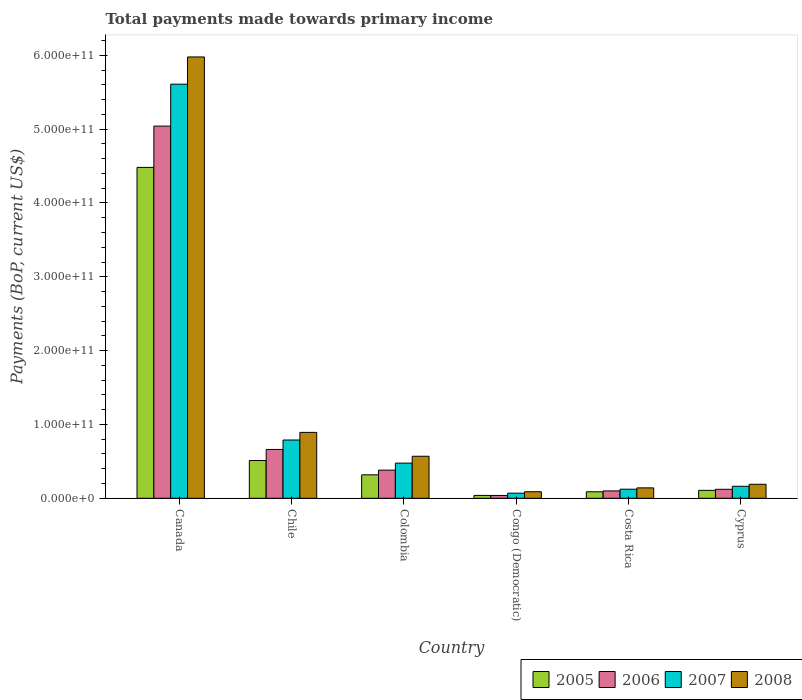How many different coloured bars are there?
Your response must be concise. 4. How many groups of bars are there?
Offer a very short reply. 6. Are the number of bars on each tick of the X-axis equal?
Ensure brevity in your answer.  Yes. How many bars are there on the 3rd tick from the left?
Offer a very short reply. 4. How many bars are there on the 3rd tick from the right?
Provide a short and direct response. 4. What is the label of the 4th group of bars from the left?
Make the answer very short. Congo (Democratic). What is the total payments made towards primary income in 2008 in Congo (Democratic)?
Keep it short and to the point. 8.86e+09. Across all countries, what is the maximum total payments made towards primary income in 2007?
Give a very brief answer. 5.61e+11. Across all countries, what is the minimum total payments made towards primary income in 2008?
Make the answer very short. 8.86e+09. In which country was the total payments made towards primary income in 2005 minimum?
Offer a terse response. Congo (Democratic). What is the total total payments made towards primary income in 2007 in the graph?
Provide a succinct answer. 7.23e+11. What is the difference between the total payments made towards primary income in 2008 in Costa Rica and that in Cyprus?
Your answer should be very brief. -4.88e+09. What is the difference between the total payments made towards primary income in 2007 in Congo (Democratic) and the total payments made towards primary income in 2008 in Canada?
Your answer should be very brief. -5.91e+11. What is the average total payments made towards primary income in 2006 per country?
Offer a terse response. 1.06e+11. What is the difference between the total payments made towards primary income of/in 2006 and total payments made towards primary income of/in 2007 in Congo (Democratic)?
Offer a very short reply. -3.07e+09. In how many countries, is the total payments made towards primary income in 2007 greater than 180000000000 US$?
Ensure brevity in your answer.  1. What is the ratio of the total payments made towards primary income in 2005 in Congo (Democratic) to that in Costa Rica?
Offer a very short reply. 0.44. Is the difference between the total payments made towards primary income in 2006 in Chile and Colombia greater than the difference between the total payments made towards primary income in 2007 in Chile and Colombia?
Your response must be concise. No. What is the difference between the highest and the second highest total payments made towards primary income in 2006?
Offer a terse response. 4.38e+11. What is the difference between the highest and the lowest total payments made towards primary income in 2006?
Ensure brevity in your answer.  5.00e+11. In how many countries, is the total payments made towards primary income in 2005 greater than the average total payments made towards primary income in 2005 taken over all countries?
Your response must be concise. 1. Is the sum of the total payments made towards primary income in 2005 in Canada and Colombia greater than the maximum total payments made towards primary income in 2006 across all countries?
Offer a very short reply. No. What does the 4th bar from the left in Congo (Democratic) represents?
Give a very brief answer. 2008. Is it the case that in every country, the sum of the total payments made towards primary income in 2007 and total payments made towards primary income in 2006 is greater than the total payments made towards primary income in 2005?
Offer a terse response. Yes. How many bars are there?
Provide a succinct answer. 24. Are all the bars in the graph horizontal?
Provide a short and direct response. No. How many countries are there in the graph?
Keep it short and to the point. 6. What is the difference between two consecutive major ticks on the Y-axis?
Give a very brief answer. 1.00e+11. Does the graph contain grids?
Your answer should be compact. No. What is the title of the graph?
Offer a terse response. Total payments made towards primary income. Does "1965" appear as one of the legend labels in the graph?
Ensure brevity in your answer.  No. What is the label or title of the X-axis?
Keep it short and to the point. Country. What is the label or title of the Y-axis?
Keep it short and to the point. Payments (BoP, current US$). What is the Payments (BoP, current US$) in 2005 in Canada?
Make the answer very short. 4.48e+11. What is the Payments (BoP, current US$) in 2006 in Canada?
Offer a very short reply. 5.04e+11. What is the Payments (BoP, current US$) of 2007 in Canada?
Your answer should be compact. 5.61e+11. What is the Payments (BoP, current US$) in 2008 in Canada?
Keep it short and to the point. 5.98e+11. What is the Payments (BoP, current US$) in 2005 in Chile?
Your response must be concise. 5.12e+1. What is the Payments (BoP, current US$) of 2006 in Chile?
Keep it short and to the point. 6.61e+1. What is the Payments (BoP, current US$) of 2007 in Chile?
Make the answer very short. 7.89e+1. What is the Payments (BoP, current US$) of 2008 in Chile?
Ensure brevity in your answer.  8.92e+1. What is the Payments (BoP, current US$) in 2005 in Colombia?
Provide a short and direct response. 3.18e+1. What is the Payments (BoP, current US$) in 2006 in Colombia?
Your response must be concise. 3.81e+1. What is the Payments (BoP, current US$) in 2007 in Colombia?
Ensure brevity in your answer.  4.76e+1. What is the Payments (BoP, current US$) of 2008 in Colombia?
Provide a succinct answer. 5.69e+1. What is the Payments (BoP, current US$) of 2005 in Congo (Democratic)?
Make the answer very short. 3.89e+09. What is the Payments (BoP, current US$) in 2006 in Congo (Democratic)?
Offer a terse response. 3.83e+09. What is the Payments (BoP, current US$) of 2007 in Congo (Democratic)?
Make the answer very short. 6.90e+09. What is the Payments (BoP, current US$) of 2008 in Congo (Democratic)?
Provide a short and direct response. 8.86e+09. What is the Payments (BoP, current US$) of 2005 in Costa Rica?
Your response must be concise. 8.79e+09. What is the Payments (BoP, current US$) in 2006 in Costa Rica?
Provide a short and direct response. 9.98e+09. What is the Payments (BoP, current US$) of 2007 in Costa Rica?
Your response must be concise. 1.23e+1. What is the Payments (BoP, current US$) in 2008 in Costa Rica?
Ensure brevity in your answer.  1.41e+1. What is the Payments (BoP, current US$) of 2005 in Cyprus?
Ensure brevity in your answer.  1.07e+1. What is the Payments (BoP, current US$) of 2006 in Cyprus?
Keep it short and to the point. 1.22e+1. What is the Payments (BoP, current US$) in 2007 in Cyprus?
Provide a short and direct response. 1.63e+1. What is the Payments (BoP, current US$) in 2008 in Cyprus?
Give a very brief answer. 1.90e+1. Across all countries, what is the maximum Payments (BoP, current US$) of 2005?
Ensure brevity in your answer.  4.48e+11. Across all countries, what is the maximum Payments (BoP, current US$) of 2006?
Ensure brevity in your answer.  5.04e+11. Across all countries, what is the maximum Payments (BoP, current US$) of 2007?
Your answer should be very brief. 5.61e+11. Across all countries, what is the maximum Payments (BoP, current US$) of 2008?
Give a very brief answer. 5.98e+11. Across all countries, what is the minimum Payments (BoP, current US$) of 2005?
Offer a terse response. 3.89e+09. Across all countries, what is the minimum Payments (BoP, current US$) in 2006?
Your response must be concise. 3.83e+09. Across all countries, what is the minimum Payments (BoP, current US$) of 2007?
Ensure brevity in your answer.  6.90e+09. Across all countries, what is the minimum Payments (BoP, current US$) of 2008?
Your answer should be compact. 8.86e+09. What is the total Payments (BoP, current US$) of 2005 in the graph?
Offer a very short reply. 5.55e+11. What is the total Payments (BoP, current US$) in 2006 in the graph?
Your answer should be very brief. 6.34e+11. What is the total Payments (BoP, current US$) in 2007 in the graph?
Your answer should be very brief. 7.23e+11. What is the total Payments (BoP, current US$) in 2008 in the graph?
Your response must be concise. 7.86e+11. What is the difference between the Payments (BoP, current US$) in 2005 in Canada and that in Chile?
Keep it short and to the point. 3.97e+11. What is the difference between the Payments (BoP, current US$) in 2006 in Canada and that in Chile?
Keep it short and to the point. 4.38e+11. What is the difference between the Payments (BoP, current US$) of 2007 in Canada and that in Chile?
Your answer should be very brief. 4.82e+11. What is the difference between the Payments (BoP, current US$) of 2008 in Canada and that in Chile?
Keep it short and to the point. 5.09e+11. What is the difference between the Payments (BoP, current US$) in 2005 in Canada and that in Colombia?
Offer a very short reply. 4.16e+11. What is the difference between the Payments (BoP, current US$) of 2006 in Canada and that in Colombia?
Provide a succinct answer. 4.66e+11. What is the difference between the Payments (BoP, current US$) of 2007 in Canada and that in Colombia?
Your answer should be compact. 5.13e+11. What is the difference between the Payments (BoP, current US$) of 2008 in Canada and that in Colombia?
Keep it short and to the point. 5.41e+11. What is the difference between the Payments (BoP, current US$) in 2005 in Canada and that in Congo (Democratic)?
Your answer should be compact. 4.44e+11. What is the difference between the Payments (BoP, current US$) of 2006 in Canada and that in Congo (Democratic)?
Make the answer very short. 5.00e+11. What is the difference between the Payments (BoP, current US$) in 2007 in Canada and that in Congo (Democratic)?
Provide a succinct answer. 5.54e+11. What is the difference between the Payments (BoP, current US$) in 2008 in Canada and that in Congo (Democratic)?
Ensure brevity in your answer.  5.89e+11. What is the difference between the Payments (BoP, current US$) of 2005 in Canada and that in Costa Rica?
Provide a short and direct response. 4.39e+11. What is the difference between the Payments (BoP, current US$) in 2006 in Canada and that in Costa Rica?
Keep it short and to the point. 4.94e+11. What is the difference between the Payments (BoP, current US$) in 2007 in Canada and that in Costa Rica?
Provide a succinct answer. 5.49e+11. What is the difference between the Payments (BoP, current US$) in 2008 in Canada and that in Costa Rica?
Keep it short and to the point. 5.84e+11. What is the difference between the Payments (BoP, current US$) of 2005 in Canada and that in Cyprus?
Provide a short and direct response. 4.37e+11. What is the difference between the Payments (BoP, current US$) of 2006 in Canada and that in Cyprus?
Ensure brevity in your answer.  4.92e+11. What is the difference between the Payments (BoP, current US$) of 2007 in Canada and that in Cyprus?
Your answer should be very brief. 5.45e+11. What is the difference between the Payments (BoP, current US$) of 2008 in Canada and that in Cyprus?
Provide a short and direct response. 5.79e+11. What is the difference between the Payments (BoP, current US$) in 2005 in Chile and that in Colombia?
Make the answer very short. 1.94e+1. What is the difference between the Payments (BoP, current US$) of 2006 in Chile and that in Colombia?
Your answer should be very brief. 2.80e+1. What is the difference between the Payments (BoP, current US$) of 2007 in Chile and that in Colombia?
Offer a very short reply. 3.13e+1. What is the difference between the Payments (BoP, current US$) of 2008 in Chile and that in Colombia?
Offer a terse response. 3.23e+1. What is the difference between the Payments (BoP, current US$) in 2005 in Chile and that in Congo (Democratic)?
Offer a very short reply. 4.73e+1. What is the difference between the Payments (BoP, current US$) of 2006 in Chile and that in Congo (Democratic)?
Your response must be concise. 6.23e+1. What is the difference between the Payments (BoP, current US$) in 2007 in Chile and that in Congo (Democratic)?
Provide a succinct answer. 7.20e+1. What is the difference between the Payments (BoP, current US$) of 2008 in Chile and that in Congo (Democratic)?
Provide a succinct answer. 8.04e+1. What is the difference between the Payments (BoP, current US$) of 2005 in Chile and that in Costa Rica?
Give a very brief answer. 4.24e+1. What is the difference between the Payments (BoP, current US$) in 2006 in Chile and that in Costa Rica?
Your answer should be compact. 5.62e+1. What is the difference between the Payments (BoP, current US$) of 2007 in Chile and that in Costa Rica?
Ensure brevity in your answer.  6.66e+1. What is the difference between the Payments (BoP, current US$) of 2008 in Chile and that in Costa Rica?
Your answer should be compact. 7.52e+1. What is the difference between the Payments (BoP, current US$) of 2005 in Chile and that in Cyprus?
Offer a very short reply. 4.04e+1. What is the difference between the Payments (BoP, current US$) of 2006 in Chile and that in Cyprus?
Offer a terse response. 5.40e+1. What is the difference between the Payments (BoP, current US$) in 2007 in Chile and that in Cyprus?
Offer a terse response. 6.27e+1. What is the difference between the Payments (BoP, current US$) of 2008 in Chile and that in Cyprus?
Give a very brief answer. 7.03e+1. What is the difference between the Payments (BoP, current US$) of 2005 in Colombia and that in Congo (Democratic)?
Make the answer very short. 2.79e+1. What is the difference between the Payments (BoP, current US$) of 2006 in Colombia and that in Congo (Democratic)?
Your answer should be very brief. 3.43e+1. What is the difference between the Payments (BoP, current US$) in 2007 in Colombia and that in Congo (Democratic)?
Your answer should be very brief. 4.07e+1. What is the difference between the Payments (BoP, current US$) in 2008 in Colombia and that in Congo (Democratic)?
Keep it short and to the point. 4.81e+1. What is the difference between the Payments (BoP, current US$) in 2005 in Colombia and that in Costa Rica?
Make the answer very short. 2.30e+1. What is the difference between the Payments (BoP, current US$) in 2006 in Colombia and that in Costa Rica?
Keep it short and to the point. 2.81e+1. What is the difference between the Payments (BoP, current US$) of 2007 in Colombia and that in Costa Rica?
Keep it short and to the point. 3.53e+1. What is the difference between the Payments (BoP, current US$) in 2008 in Colombia and that in Costa Rica?
Ensure brevity in your answer.  4.28e+1. What is the difference between the Payments (BoP, current US$) in 2005 in Colombia and that in Cyprus?
Provide a short and direct response. 2.10e+1. What is the difference between the Payments (BoP, current US$) of 2006 in Colombia and that in Cyprus?
Keep it short and to the point. 2.59e+1. What is the difference between the Payments (BoP, current US$) in 2007 in Colombia and that in Cyprus?
Make the answer very short. 3.14e+1. What is the difference between the Payments (BoP, current US$) of 2008 in Colombia and that in Cyprus?
Your response must be concise. 3.80e+1. What is the difference between the Payments (BoP, current US$) in 2005 in Congo (Democratic) and that in Costa Rica?
Your answer should be compact. -4.89e+09. What is the difference between the Payments (BoP, current US$) in 2006 in Congo (Democratic) and that in Costa Rica?
Offer a terse response. -6.15e+09. What is the difference between the Payments (BoP, current US$) of 2007 in Congo (Democratic) and that in Costa Rica?
Your answer should be very brief. -5.40e+09. What is the difference between the Payments (BoP, current US$) of 2008 in Congo (Democratic) and that in Costa Rica?
Ensure brevity in your answer.  -5.23e+09. What is the difference between the Payments (BoP, current US$) in 2005 in Congo (Democratic) and that in Cyprus?
Ensure brevity in your answer.  -6.85e+09. What is the difference between the Payments (BoP, current US$) of 2006 in Congo (Democratic) and that in Cyprus?
Ensure brevity in your answer.  -8.35e+09. What is the difference between the Payments (BoP, current US$) in 2007 in Congo (Democratic) and that in Cyprus?
Provide a succinct answer. -9.37e+09. What is the difference between the Payments (BoP, current US$) in 2008 in Congo (Democratic) and that in Cyprus?
Provide a short and direct response. -1.01e+1. What is the difference between the Payments (BoP, current US$) in 2005 in Costa Rica and that in Cyprus?
Offer a very short reply. -1.96e+09. What is the difference between the Payments (BoP, current US$) of 2006 in Costa Rica and that in Cyprus?
Provide a short and direct response. -2.20e+09. What is the difference between the Payments (BoP, current US$) in 2007 in Costa Rica and that in Cyprus?
Offer a terse response. -3.97e+09. What is the difference between the Payments (BoP, current US$) of 2008 in Costa Rica and that in Cyprus?
Offer a terse response. -4.88e+09. What is the difference between the Payments (BoP, current US$) of 2005 in Canada and the Payments (BoP, current US$) of 2006 in Chile?
Ensure brevity in your answer.  3.82e+11. What is the difference between the Payments (BoP, current US$) in 2005 in Canada and the Payments (BoP, current US$) in 2007 in Chile?
Give a very brief answer. 3.69e+11. What is the difference between the Payments (BoP, current US$) in 2005 in Canada and the Payments (BoP, current US$) in 2008 in Chile?
Provide a succinct answer. 3.59e+11. What is the difference between the Payments (BoP, current US$) in 2006 in Canada and the Payments (BoP, current US$) in 2007 in Chile?
Keep it short and to the point. 4.25e+11. What is the difference between the Payments (BoP, current US$) in 2006 in Canada and the Payments (BoP, current US$) in 2008 in Chile?
Give a very brief answer. 4.15e+11. What is the difference between the Payments (BoP, current US$) in 2007 in Canada and the Payments (BoP, current US$) in 2008 in Chile?
Keep it short and to the point. 4.72e+11. What is the difference between the Payments (BoP, current US$) in 2005 in Canada and the Payments (BoP, current US$) in 2006 in Colombia?
Give a very brief answer. 4.10e+11. What is the difference between the Payments (BoP, current US$) of 2005 in Canada and the Payments (BoP, current US$) of 2007 in Colombia?
Offer a terse response. 4.01e+11. What is the difference between the Payments (BoP, current US$) in 2005 in Canada and the Payments (BoP, current US$) in 2008 in Colombia?
Keep it short and to the point. 3.91e+11. What is the difference between the Payments (BoP, current US$) in 2006 in Canada and the Payments (BoP, current US$) in 2007 in Colombia?
Your answer should be compact. 4.56e+11. What is the difference between the Payments (BoP, current US$) in 2006 in Canada and the Payments (BoP, current US$) in 2008 in Colombia?
Keep it short and to the point. 4.47e+11. What is the difference between the Payments (BoP, current US$) of 2007 in Canada and the Payments (BoP, current US$) of 2008 in Colombia?
Provide a succinct answer. 5.04e+11. What is the difference between the Payments (BoP, current US$) in 2005 in Canada and the Payments (BoP, current US$) in 2006 in Congo (Democratic)?
Provide a succinct answer. 4.44e+11. What is the difference between the Payments (BoP, current US$) of 2005 in Canada and the Payments (BoP, current US$) of 2007 in Congo (Democratic)?
Ensure brevity in your answer.  4.41e+11. What is the difference between the Payments (BoP, current US$) of 2005 in Canada and the Payments (BoP, current US$) of 2008 in Congo (Democratic)?
Provide a succinct answer. 4.39e+11. What is the difference between the Payments (BoP, current US$) in 2006 in Canada and the Payments (BoP, current US$) in 2007 in Congo (Democratic)?
Offer a terse response. 4.97e+11. What is the difference between the Payments (BoP, current US$) in 2006 in Canada and the Payments (BoP, current US$) in 2008 in Congo (Democratic)?
Your response must be concise. 4.95e+11. What is the difference between the Payments (BoP, current US$) in 2007 in Canada and the Payments (BoP, current US$) in 2008 in Congo (Democratic)?
Keep it short and to the point. 5.52e+11. What is the difference between the Payments (BoP, current US$) in 2005 in Canada and the Payments (BoP, current US$) in 2006 in Costa Rica?
Provide a short and direct response. 4.38e+11. What is the difference between the Payments (BoP, current US$) of 2005 in Canada and the Payments (BoP, current US$) of 2007 in Costa Rica?
Your answer should be compact. 4.36e+11. What is the difference between the Payments (BoP, current US$) of 2005 in Canada and the Payments (BoP, current US$) of 2008 in Costa Rica?
Ensure brevity in your answer.  4.34e+11. What is the difference between the Payments (BoP, current US$) in 2006 in Canada and the Payments (BoP, current US$) in 2007 in Costa Rica?
Offer a terse response. 4.92e+11. What is the difference between the Payments (BoP, current US$) in 2006 in Canada and the Payments (BoP, current US$) in 2008 in Costa Rica?
Your response must be concise. 4.90e+11. What is the difference between the Payments (BoP, current US$) of 2007 in Canada and the Payments (BoP, current US$) of 2008 in Costa Rica?
Make the answer very short. 5.47e+11. What is the difference between the Payments (BoP, current US$) of 2005 in Canada and the Payments (BoP, current US$) of 2006 in Cyprus?
Keep it short and to the point. 4.36e+11. What is the difference between the Payments (BoP, current US$) of 2005 in Canada and the Payments (BoP, current US$) of 2007 in Cyprus?
Your answer should be very brief. 4.32e+11. What is the difference between the Payments (BoP, current US$) of 2005 in Canada and the Payments (BoP, current US$) of 2008 in Cyprus?
Make the answer very short. 4.29e+11. What is the difference between the Payments (BoP, current US$) of 2006 in Canada and the Payments (BoP, current US$) of 2007 in Cyprus?
Offer a very short reply. 4.88e+11. What is the difference between the Payments (BoP, current US$) in 2006 in Canada and the Payments (BoP, current US$) in 2008 in Cyprus?
Give a very brief answer. 4.85e+11. What is the difference between the Payments (BoP, current US$) in 2007 in Canada and the Payments (BoP, current US$) in 2008 in Cyprus?
Offer a terse response. 5.42e+11. What is the difference between the Payments (BoP, current US$) of 2005 in Chile and the Payments (BoP, current US$) of 2006 in Colombia?
Ensure brevity in your answer.  1.31e+1. What is the difference between the Payments (BoP, current US$) in 2005 in Chile and the Payments (BoP, current US$) in 2007 in Colombia?
Offer a very short reply. 3.56e+09. What is the difference between the Payments (BoP, current US$) of 2005 in Chile and the Payments (BoP, current US$) of 2008 in Colombia?
Make the answer very short. -5.74e+09. What is the difference between the Payments (BoP, current US$) in 2006 in Chile and the Payments (BoP, current US$) in 2007 in Colombia?
Provide a short and direct response. 1.85e+1. What is the difference between the Payments (BoP, current US$) in 2006 in Chile and the Payments (BoP, current US$) in 2008 in Colombia?
Offer a terse response. 9.21e+09. What is the difference between the Payments (BoP, current US$) in 2007 in Chile and the Payments (BoP, current US$) in 2008 in Colombia?
Your answer should be compact. 2.20e+1. What is the difference between the Payments (BoP, current US$) of 2005 in Chile and the Payments (BoP, current US$) of 2006 in Congo (Democratic)?
Provide a succinct answer. 4.74e+1. What is the difference between the Payments (BoP, current US$) of 2005 in Chile and the Payments (BoP, current US$) of 2007 in Congo (Democratic)?
Give a very brief answer. 4.43e+1. What is the difference between the Payments (BoP, current US$) in 2005 in Chile and the Payments (BoP, current US$) in 2008 in Congo (Democratic)?
Ensure brevity in your answer.  4.23e+1. What is the difference between the Payments (BoP, current US$) of 2006 in Chile and the Payments (BoP, current US$) of 2007 in Congo (Democratic)?
Provide a short and direct response. 5.92e+1. What is the difference between the Payments (BoP, current US$) of 2006 in Chile and the Payments (BoP, current US$) of 2008 in Congo (Democratic)?
Offer a very short reply. 5.73e+1. What is the difference between the Payments (BoP, current US$) of 2007 in Chile and the Payments (BoP, current US$) of 2008 in Congo (Democratic)?
Offer a very short reply. 7.01e+1. What is the difference between the Payments (BoP, current US$) in 2005 in Chile and the Payments (BoP, current US$) in 2006 in Costa Rica?
Your response must be concise. 4.12e+1. What is the difference between the Payments (BoP, current US$) of 2005 in Chile and the Payments (BoP, current US$) of 2007 in Costa Rica?
Your answer should be compact. 3.89e+1. What is the difference between the Payments (BoP, current US$) in 2005 in Chile and the Payments (BoP, current US$) in 2008 in Costa Rica?
Your answer should be compact. 3.71e+1. What is the difference between the Payments (BoP, current US$) in 2006 in Chile and the Payments (BoP, current US$) in 2007 in Costa Rica?
Offer a terse response. 5.38e+1. What is the difference between the Payments (BoP, current US$) in 2006 in Chile and the Payments (BoP, current US$) in 2008 in Costa Rica?
Make the answer very short. 5.20e+1. What is the difference between the Payments (BoP, current US$) in 2007 in Chile and the Payments (BoP, current US$) in 2008 in Costa Rica?
Your answer should be very brief. 6.48e+1. What is the difference between the Payments (BoP, current US$) in 2005 in Chile and the Payments (BoP, current US$) in 2006 in Cyprus?
Offer a terse response. 3.90e+1. What is the difference between the Payments (BoP, current US$) of 2005 in Chile and the Payments (BoP, current US$) of 2007 in Cyprus?
Ensure brevity in your answer.  3.49e+1. What is the difference between the Payments (BoP, current US$) of 2005 in Chile and the Payments (BoP, current US$) of 2008 in Cyprus?
Your answer should be very brief. 3.22e+1. What is the difference between the Payments (BoP, current US$) in 2006 in Chile and the Payments (BoP, current US$) in 2007 in Cyprus?
Offer a very short reply. 4.99e+1. What is the difference between the Payments (BoP, current US$) of 2006 in Chile and the Payments (BoP, current US$) of 2008 in Cyprus?
Your answer should be very brief. 4.72e+1. What is the difference between the Payments (BoP, current US$) of 2007 in Chile and the Payments (BoP, current US$) of 2008 in Cyprus?
Your response must be concise. 6.00e+1. What is the difference between the Payments (BoP, current US$) in 2005 in Colombia and the Payments (BoP, current US$) in 2006 in Congo (Democratic)?
Give a very brief answer. 2.79e+1. What is the difference between the Payments (BoP, current US$) of 2005 in Colombia and the Payments (BoP, current US$) of 2007 in Congo (Democratic)?
Your answer should be very brief. 2.49e+1. What is the difference between the Payments (BoP, current US$) of 2005 in Colombia and the Payments (BoP, current US$) of 2008 in Congo (Democratic)?
Make the answer very short. 2.29e+1. What is the difference between the Payments (BoP, current US$) in 2006 in Colombia and the Payments (BoP, current US$) in 2007 in Congo (Democratic)?
Your response must be concise. 3.12e+1. What is the difference between the Payments (BoP, current US$) of 2006 in Colombia and the Payments (BoP, current US$) of 2008 in Congo (Democratic)?
Offer a very short reply. 2.93e+1. What is the difference between the Payments (BoP, current US$) of 2007 in Colombia and the Payments (BoP, current US$) of 2008 in Congo (Democratic)?
Provide a short and direct response. 3.88e+1. What is the difference between the Payments (BoP, current US$) of 2005 in Colombia and the Payments (BoP, current US$) of 2006 in Costa Rica?
Your answer should be compact. 2.18e+1. What is the difference between the Payments (BoP, current US$) in 2005 in Colombia and the Payments (BoP, current US$) in 2007 in Costa Rica?
Your answer should be compact. 1.95e+1. What is the difference between the Payments (BoP, current US$) in 2005 in Colombia and the Payments (BoP, current US$) in 2008 in Costa Rica?
Your answer should be very brief. 1.77e+1. What is the difference between the Payments (BoP, current US$) in 2006 in Colombia and the Payments (BoP, current US$) in 2007 in Costa Rica?
Offer a terse response. 2.58e+1. What is the difference between the Payments (BoP, current US$) of 2006 in Colombia and the Payments (BoP, current US$) of 2008 in Costa Rica?
Provide a short and direct response. 2.40e+1. What is the difference between the Payments (BoP, current US$) in 2007 in Colombia and the Payments (BoP, current US$) in 2008 in Costa Rica?
Keep it short and to the point. 3.35e+1. What is the difference between the Payments (BoP, current US$) in 2005 in Colombia and the Payments (BoP, current US$) in 2006 in Cyprus?
Your answer should be very brief. 1.96e+1. What is the difference between the Payments (BoP, current US$) of 2005 in Colombia and the Payments (BoP, current US$) of 2007 in Cyprus?
Make the answer very short. 1.55e+1. What is the difference between the Payments (BoP, current US$) of 2005 in Colombia and the Payments (BoP, current US$) of 2008 in Cyprus?
Your answer should be compact. 1.28e+1. What is the difference between the Payments (BoP, current US$) in 2006 in Colombia and the Payments (BoP, current US$) in 2007 in Cyprus?
Give a very brief answer. 2.19e+1. What is the difference between the Payments (BoP, current US$) in 2006 in Colombia and the Payments (BoP, current US$) in 2008 in Cyprus?
Your response must be concise. 1.91e+1. What is the difference between the Payments (BoP, current US$) of 2007 in Colombia and the Payments (BoP, current US$) of 2008 in Cyprus?
Offer a very short reply. 2.87e+1. What is the difference between the Payments (BoP, current US$) in 2005 in Congo (Democratic) and the Payments (BoP, current US$) in 2006 in Costa Rica?
Offer a very short reply. -6.08e+09. What is the difference between the Payments (BoP, current US$) of 2005 in Congo (Democratic) and the Payments (BoP, current US$) of 2007 in Costa Rica?
Provide a short and direct response. -8.41e+09. What is the difference between the Payments (BoP, current US$) in 2005 in Congo (Democratic) and the Payments (BoP, current US$) in 2008 in Costa Rica?
Offer a very short reply. -1.02e+1. What is the difference between the Payments (BoP, current US$) of 2006 in Congo (Democratic) and the Payments (BoP, current US$) of 2007 in Costa Rica?
Provide a short and direct response. -8.47e+09. What is the difference between the Payments (BoP, current US$) in 2006 in Congo (Democratic) and the Payments (BoP, current US$) in 2008 in Costa Rica?
Give a very brief answer. -1.03e+1. What is the difference between the Payments (BoP, current US$) of 2007 in Congo (Democratic) and the Payments (BoP, current US$) of 2008 in Costa Rica?
Ensure brevity in your answer.  -7.19e+09. What is the difference between the Payments (BoP, current US$) of 2005 in Congo (Democratic) and the Payments (BoP, current US$) of 2006 in Cyprus?
Keep it short and to the point. -8.29e+09. What is the difference between the Payments (BoP, current US$) in 2005 in Congo (Democratic) and the Payments (BoP, current US$) in 2007 in Cyprus?
Offer a very short reply. -1.24e+1. What is the difference between the Payments (BoP, current US$) of 2005 in Congo (Democratic) and the Payments (BoP, current US$) of 2008 in Cyprus?
Offer a very short reply. -1.51e+1. What is the difference between the Payments (BoP, current US$) in 2006 in Congo (Democratic) and the Payments (BoP, current US$) in 2007 in Cyprus?
Keep it short and to the point. -1.24e+1. What is the difference between the Payments (BoP, current US$) in 2006 in Congo (Democratic) and the Payments (BoP, current US$) in 2008 in Cyprus?
Offer a very short reply. -1.51e+1. What is the difference between the Payments (BoP, current US$) of 2007 in Congo (Democratic) and the Payments (BoP, current US$) of 2008 in Cyprus?
Offer a very short reply. -1.21e+1. What is the difference between the Payments (BoP, current US$) of 2005 in Costa Rica and the Payments (BoP, current US$) of 2006 in Cyprus?
Your response must be concise. -3.39e+09. What is the difference between the Payments (BoP, current US$) in 2005 in Costa Rica and the Payments (BoP, current US$) in 2007 in Cyprus?
Your answer should be very brief. -7.48e+09. What is the difference between the Payments (BoP, current US$) of 2005 in Costa Rica and the Payments (BoP, current US$) of 2008 in Cyprus?
Make the answer very short. -1.02e+1. What is the difference between the Payments (BoP, current US$) in 2006 in Costa Rica and the Payments (BoP, current US$) in 2007 in Cyprus?
Ensure brevity in your answer.  -6.29e+09. What is the difference between the Payments (BoP, current US$) in 2006 in Costa Rica and the Payments (BoP, current US$) in 2008 in Cyprus?
Ensure brevity in your answer.  -8.99e+09. What is the difference between the Payments (BoP, current US$) of 2007 in Costa Rica and the Payments (BoP, current US$) of 2008 in Cyprus?
Make the answer very short. -6.67e+09. What is the average Payments (BoP, current US$) of 2005 per country?
Your response must be concise. 9.24e+1. What is the average Payments (BoP, current US$) in 2006 per country?
Give a very brief answer. 1.06e+11. What is the average Payments (BoP, current US$) of 2007 per country?
Provide a short and direct response. 1.20e+11. What is the average Payments (BoP, current US$) in 2008 per country?
Provide a succinct answer. 1.31e+11. What is the difference between the Payments (BoP, current US$) in 2005 and Payments (BoP, current US$) in 2006 in Canada?
Provide a short and direct response. -5.59e+1. What is the difference between the Payments (BoP, current US$) in 2005 and Payments (BoP, current US$) in 2007 in Canada?
Offer a terse response. -1.13e+11. What is the difference between the Payments (BoP, current US$) of 2005 and Payments (BoP, current US$) of 2008 in Canada?
Ensure brevity in your answer.  -1.50e+11. What is the difference between the Payments (BoP, current US$) of 2006 and Payments (BoP, current US$) of 2007 in Canada?
Offer a terse response. -5.68e+1. What is the difference between the Payments (BoP, current US$) of 2006 and Payments (BoP, current US$) of 2008 in Canada?
Offer a very short reply. -9.37e+1. What is the difference between the Payments (BoP, current US$) of 2007 and Payments (BoP, current US$) of 2008 in Canada?
Offer a very short reply. -3.69e+1. What is the difference between the Payments (BoP, current US$) in 2005 and Payments (BoP, current US$) in 2006 in Chile?
Give a very brief answer. -1.49e+1. What is the difference between the Payments (BoP, current US$) of 2005 and Payments (BoP, current US$) of 2007 in Chile?
Make the answer very short. -2.77e+1. What is the difference between the Payments (BoP, current US$) in 2005 and Payments (BoP, current US$) in 2008 in Chile?
Your answer should be compact. -3.81e+1. What is the difference between the Payments (BoP, current US$) in 2006 and Payments (BoP, current US$) in 2007 in Chile?
Provide a succinct answer. -1.28e+1. What is the difference between the Payments (BoP, current US$) in 2006 and Payments (BoP, current US$) in 2008 in Chile?
Provide a succinct answer. -2.31e+1. What is the difference between the Payments (BoP, current US$) of 2007 and Payments (BoP, current US$) of 2008 in Chile?
Keep it short and to the point. -1.03e+1. What is the difference between the Payments (BoP, current US$) in 2005 and Payments (BoP, current US$) in 2006 in Colombia?
Your answer should be compact. -6.36e+09. What is the difference between the Payments (BoP, current US$) in 2005 and Payments (BoP, current US$) in 2007 in Colombia?
Give a very brief answer. -1.59e+1. What is the difference between the Payments (BoP, current US$) of 2005 and Payments (BoP, current US$) of 2008 in Colombia?
Your answer should be compact. -2.52e+1. What is the difference between the Payments (BoP, current US$) of 2006 and Payments (BoP, current US$) of 2007 in Colombia?
Your answer should be compact. -9.51e+09. What is the difference between the Payments (BoP, current US$) of 2006 and Payments (BoP, current US$) of 2008 in Colombia?
Keep it short and to the point. -1.88e+1. What is the difference between the Payments (BoP, current US$) in 2007 and Payments (BoP, current US$) in 2008 in Colombia?
Offer a terse response. -9.30e+09. What is the difference between the Payments (BoP, current US$) in 2005 and Payments (BoP, current US$) in 2006 in Congo (Democratic)?
Ensure brevity in your answer.  6.30e+07. What is the difference between the Payments (BoP, current US$) of 2005 and Payments (BoP, current US$) of 2007 in Congo (Democratic)?
Offer a very short reply. -3.01e+09. What is the difference between the Payments (BoP, current US$) of 2005 and Payments (BoP, current US$) of 2008 in Congo (Democratic)?
Your answer should be compact. -4.97e+09. What is the difference between the Payments (BoP, current US$) in 2006 and Payments (BoP, current US$) in 2007 in Congo (Democratic)?
Provide a short and direct response. -3.07e+09. What is the difference between the Payments (BoP, current US$) in 2006 and Payments (BoP, current US$) in 2008 in Congo (Democratic)?
Provide a succinct answer. -5.03e+09. What is the difference between the Payments (BoP, current US$) in 2007 and Payments (BoP, current US$) in 2008 in Congo (Democratic)?
Your answer should be very brief. -1.96e+09. What is the difference between the Payments (BoP, current US$) of 2005 and Payments (BoP, current US$) of 2006 in Costa Rica?
Provide a short and direct response. -1.19e+09. What is the difference between the Payments (BoP, current US$) of 2005 and Payments (BoP, current US$) of 2007 in Costa Rica?
Make the answer very short. -3.51e+09. What is the difference between the Payments (BoP, current US$) of 2005 and Payments (BoP, current US$) of 2008 in Costa Rica?
Give a very brief answer. -5.31e+09. What is the difference between the Payments (BoP, current US$) of 2006 and Payments (BoP, current US$) of 2007 in Costa Rica?
Your response must be concise. -2.32e+09. What is the difference between the Payments (BoP, current US$) of 2006 and Payments (BoP, current US$) of 2008 in Costa Rica?
Provide a succinct answer. -4.12e+09. What is the difference between the Payments (BoP, current US$) of 2007 and Payments (BoP, current US$) of 2008 in Costa Rica?
Provide a short and direct response. -1.79e+09. What is the difference between the Payments (BoP, current US$) of 2005 and Payments (BoP, current US$) of 2006 in Cyprus?
Ensure brevity in your answer.  -1.43e+09. What is the difference between the Payments (BoP, current US$) in 2005 and Payments (BoP, current US$) in 2007 in Cyprus?
Offer a very short reply. -5.52e+09. What is the difference between the Payments (BoP, current US$) of 2005 and Payments (BoP, current US$) of 2008 in Cyprus?
Provide a short and direct response. -8.22e+09. What is the difference between the Payments (BoP, current US$) of 2006 and Payments (BoP, current US$) of 2007 in Cyprus?
Ensure brevity in your answer.  -4.09e+09. What is the difference between the Payments (BoP, current US$) of 2006 and Payments (BoP, current US$) of 2008 in Cyprus?
Your answer should be compact. -6.79e+09. What is the difference between the Payments (BoP, current US$) in 2007 and Payments (BoP, current US$) in 2008 in Cyprus?
Make the answer very short. -2.70e+09. What is the ratio of the Payments (BoP, current US$) of 2005 in Canada to that in Chile?
Your response must be concise. 8.76. What is the ratio of the Payments (BoP, current US$) of 2006 in Canada to that in Chile?
Your response must be concise. 7.62. What is the ratio of the Payments (BoP, current US$) of 2007 in Canada to that in Chile?
Ensure brevity in your answer.  7.11. What is the ratio of the Payments (BoP, current US$) of 2008 in Canada to that in Chile?
Keep it short and to the point. 6.7. What is the ratio of the Payments (BoP, current US$) of 2005 in Canada to that in Colombia?
Provide a short and direct response. 14.11. What is the ratio of the Payments (BoP, current US$) in 2006 in Canada to that in Colombia?
Ensure brevity in your answer.  13.22. What is the ratio of the Payments (BoP, current US$) of 2007 in Canada to that in Colombia?
Offer a very short reply. 11.78. What is the ratio of the Payments (BoP, current US$) in 2008 in Canada to that in Colombia?
Your response must be concise. 10.5. What is the ratio of the Payments (BoP, current US$) of 2005 in Canada to that in Congo (Democratic)?
Offer a terse response. 115.15. What is the ratio of the Payments (BoP, current US$) of 2006 in Canada to that in Congo (Democratic)?
Offer a very short reply. 131.65. What is the ratio of the Payments (BoP, current US$) of 2007 in Canada to that in Congo (Democratic)?
Provide a short and direct response. 81.27. What is the ratio of the Payments (BoP, current US$) of 2008 in Canada to that in Congo (Democratic)?
Offer a very short reply. 67.45. What is the ratio of the Payments (BoP, current US$) in 2005 in Canada to that in Costa Rica?
Your response must be concise. 51. What is the ratio of the Payments (BoP, current US$) of 2006 in Canada to that in Costa Rica?
Your response must be concise. 50.53. What is the ratio of the Payments (BoP, current US$) in 2007 in Canada to that in Costa Rica?
Your answer should be very brief. 45.6. What is the ratio of the Payments (BoP, current US$) in 2008 in Canada to that in Costa Rica?
Keep it short and to the point. 42.42. What is the ratio of the Payments (BoP, current US$) of 2005 in Canada to that in Cyprus?
Provide a short and direct response. 41.71. What is the ratio of the Payments (BoP, current US$) in 2006 in Canada to that in Cyprus?
Make the answer very short. 41.4. What is the ratio of the Payments (BoP, current US$) of 2007 in Canada to that in Cyprus?
Ensure brevity in your answer.  34.48. What is the ratio of the Payments (BoP, current US$) in 2008 in Canada to that in Cyprus?
Provide a short and direct response. 31.51. What is the ratio of the Payments (BoP, current US$) of 2005 in Chile to that in Colombia?
Offer a terse response. 1.61. What is the ratio of the Payments (BoP, current US$) in 2006 in Chile to that in Colombia?
Keep it short and to the point. 1.74. What is the ratio of the Payments (BoP, current US$) of 2007 in Chile to that in Colombia?
Provide a short and direct response. 1.66. What is the ratio of the Payments (BoP, current US$) of 2008 in Chile to that in Colombia?
Offer a very short reply. 1.57. What is the ratio of the Payments (BoP, current US$) of 2005 in Chile to that in Congo (Democratic)?
Your answer should be very brief. 13.15. What is the ratio of the Payments (BoP, current US$) of 2006 in Chile to that in Congo (Democratic)?
Provide a short and direct response. 17.27. What is the ratio of the Payments (BoP, current US$) in 2007 in Chile to that in Congo (Democratic)?
Make the answer very short. 11.44. What is the ratio of the Payments (BoP, current US$) of 2008 in Chile to that in Congo (Democratic)?
Make the answer very short. 10.07. What is the ratio of the Payments (BoP, current US$) of 2005 in Chile to that in Costa Rica?
Your response must be concise. 5.83. What is the ratio of the Payments (BoP, current US$) of 2006 in Chile to that in Costa Rica?
Give a very brief answer. 6.63. What is the ratio of the Payments (BoP, current US$) in 2007 in Chile to that in Costa Rica?
Offer a very short reply. 6.42. What is the ratio of the Payments (BoP, current US$) of 2008 in Chile to that in Costa Rica?
Make the answer very short. 6.33. What is the ratio of the Payments (BoP, current US$) of 2005 in Chile to that in Cyprus?
Provide a succinct answer. 4.76. What is the ratio of the Payments (BoP, current US$) in 2006 in Chile to that in Cyprus?
Provide a short and direct response. 5.43. What is the ratio of the Payments (BoP, current US$) in 2007 in Chile to that in Cyprus?
Your answer should be compact. 4.85. What is the ratio of the Payments (BoP, current US$) in 2008 in Chile to that in Cyprus?
Make the answer very short. 4.71. What is the ratio of the Payments (BoP, current US$) in 2005 in Colombia to that in Congo (Democratic)?
Ensure brevity in your answer.  8.16. What is the ratio of the Payments (BoP, current US$) in 2006 in Colombia to that in Congo (Democratic)?
Offer a terse response. 9.96. What is the ratio of the Payments (BoP, current US$) in 2007 in Colombia to that in Congo (Democratic)?
Keep it short and to the point. 6.9. What is the ratio of the Payments (BoP, current US$) of 2008 in Colombia to that in Congo (Democratic)?
Offer a very short reply. 6.42. What is the ratio of the Payments (BoP, current US$) in 2005 in Colombia to that in Costa Rica?
Offer a terse response. 3.61. What is the ratio of the Payments (BoP, current US$) in 2006 in Colombia to that in Costa Rica?
Offer a very short reply. 3.82. What is the ratio of the Payments (BoP, current US$) in 2007 in Colombia to that in Costa Rica?
Your answer should be very brief. 3.87. What is the ratio of the Payments (BoP, current US$) of 2008 in Colombia to that in Costa Rica?
Keep it short and to the point. 4.04. What is the ratio of the Payments (BoP, current US$) of 2005 in Colombia to that in Cyprus?
Keep it short and to the point. 2.96. What is the ratio of the Payments (BoP, current US$) in 2006 in Colombia to that in Cyprus?
Offer a very short reply. 3.13. What is the ratio of the Payments (BoP, current US$) in 2007 in Colombia to that in Cyprus?
Give a very brief answer. 2.93. What is the ratio of the Payments (BoP, current US$) in 2008 in Colombia to that in Cyprus?
Make the answer very short. 3. What is the ratio of the Payments (BoP, current US$) in 2005 in Congo (Democratic) to that in Costa Rica?
Your response must be concise. 0.44. What is the ratio of the Payments (BoP, current US$) in 2006 in Congo (Democratic) to that in Costa Rica?
Give a very brief answer. 0.38. What is the ratio of the Payments (BoP, current US$) of 2007 in Congo (Democratic) to that in Costa Rica?
Ensure brevity in your answer.  0.56. What is the ratio of the Payments (BoP, current US$) of 2008 in Congo (Democratic) to that in Costa Rica?
Keep it short and to the point. 0.63. What is the ratio of the Payments (BoP, current US$) of 2005 in Congo (Democratic) to that in Cyprus?
Give a very brief answer. 0.36. What is the ratio of the Payments (BoP, current US$) in 2006 in Congo (Democratic) to that in Cyprus?
Your answer should be compact. 0.31. What is the ratio of the Payments (BoP, current US$) of 2007 in Congo (Democratic) to that in Cyprus?
Offer a terse response. 0.42. What is the ratio of the Payments (BoP, current US$) in 2008 in Congo (Democratic) to that in Cyprus?
Offer a terse response. 0.47. What is the ratio of the Payments (BoP, current US$) of 2005 in Costa Rica to that in Cyprus?
Provide a short and direct response. 0.82. What is the ratio of the Payments (BoP, current US$) in 2006 in Costa Rica to that in Cyprus?
Ensure brevity in your answer.  0.82. What is the ratio of the Payments (BoP, current US$) of 2007 in Costa Rica to that in Cyprus?
Give a very brief answer. 0.76. What is the ratio of the Payments (BoP, current US$) of 2008 in Costa Rica to that in Cyprus?
Give a very brief answer. 0.74. What is the difference between the highest and the second highest Payments (BoP, current US$) of 2005?
Offer a very short reply. 3.97e+11. What is the difference between the highest and the second highest Payments (BoP, current US$) in 2006?
Offer a very short reply. 4.38e+11. What is the difference between the highest and the second highest Payments (BoP, current US$) in 2007?
Provide a short and direct response. 4.82e+11. What is the difference between the highest and the second highest Payments (BoP, current US$) in 2008?
Provide a short and direct response. 5.09e+11. What is the difference between the highest and the lowest Payments (BoP, current US$) in 2005?
Your response must be concise. 4.44e+11. What is the difference between the highest and the lowest Payments (BoP, current US$) in 2006?
Offer a terse response. 5.00e+11. What is the difference between the highest and the lowest Payments (BoP, current US$) of 2007?
Make the answer very short. 5.54e+11. What is the difference between the highest and the lowest Payments (BoP, current US$) in 2008?
Make the answer very short. 5.89e+11. 